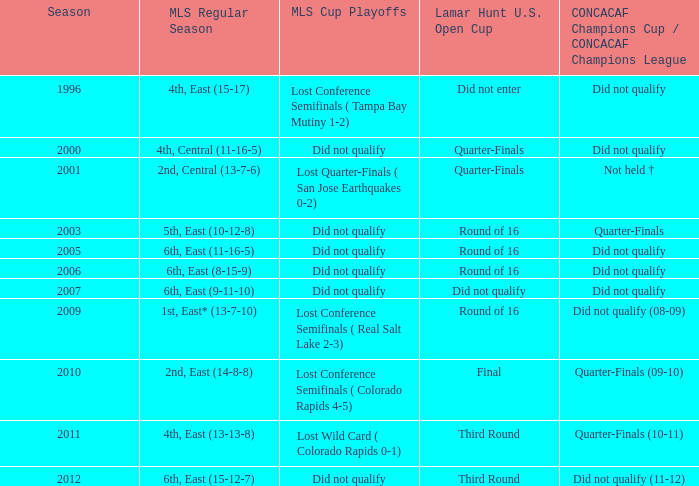How many entries are there for season where mls regular season was 5th, east (10-12-8)? 1.0. 